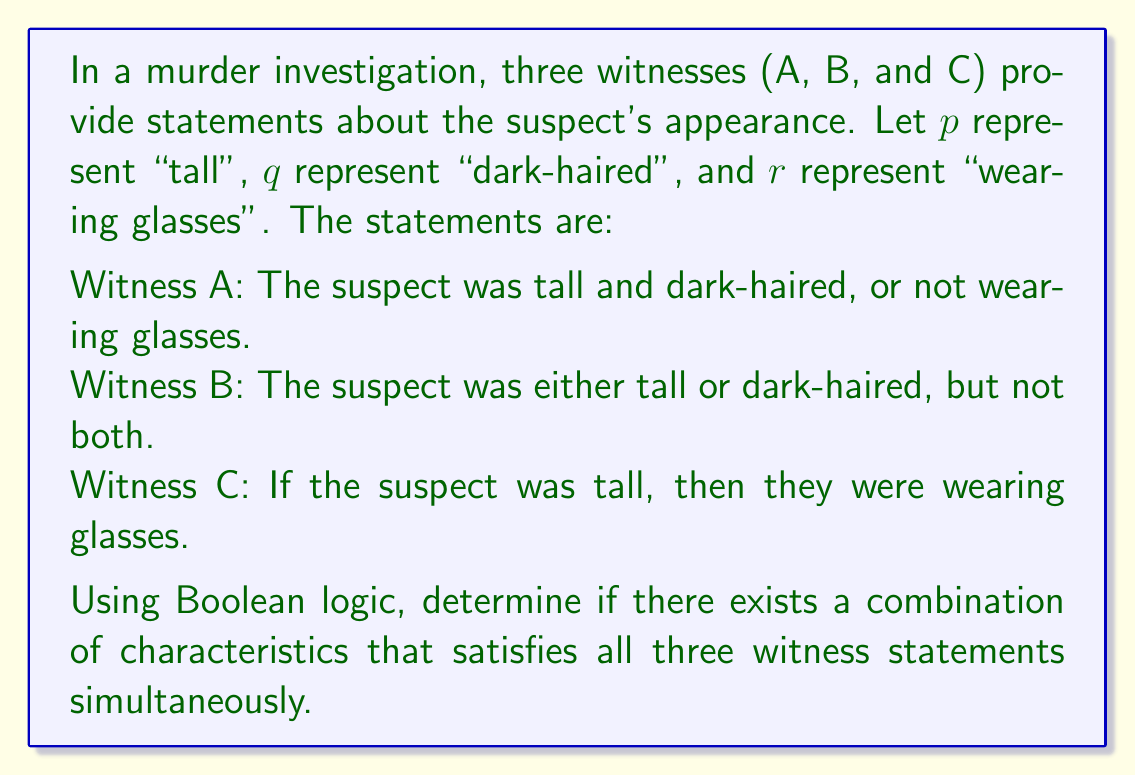Can you answer this question? Let's approach this step-by-step using Boolean algebra:

1. Translate each witness statement into a Boolean expression:
   Witness A: $(p \wedge q) \vee \neg r$
   Witness B: $(p \oplus q)$ (exclusive OR)
   Witness C: $p \rightarrow r$

2. We need to find a combination of $p$, $q$, and $r$ that makes all three statements true.

3. Let's consider Witness B's statement first, as it's the most restrictive. It can be true in two cases:
   Case 1: $p = 1, q = 0$
   Case 2: $p = 0, q = 1$

4. Now, let's consider each case:

   Case 1 ($p = 1, q = 0$):
   - For Witness A: $(1 \wedge 0) \vee \neg r = \neg r$, which is true if $r = 0$
   - For Witness C: $1 \rightarrow r$ is true only if $r = 1$
   This case leads to a contradiction, so it's not valid.

   Case 2 ($p = 0, q = 1$):
   - For Witness A: $(0 \wedge 1) \vee \neg r = \neg r$, which is true if $r = 0$
   - For Witness C: $0 \rightarrow r$ is always true regardless of $r$

5. Therefore, the only consistent combination is:
   $p = 0$ (not tall)
   $q = 1$ (dark-haired)
   $r = 0$ (not wearing glasses)

This combination satisfies all three witness statements simultaneously.
Answer: Yes, $p = 0, q = 1, r = 0$ 